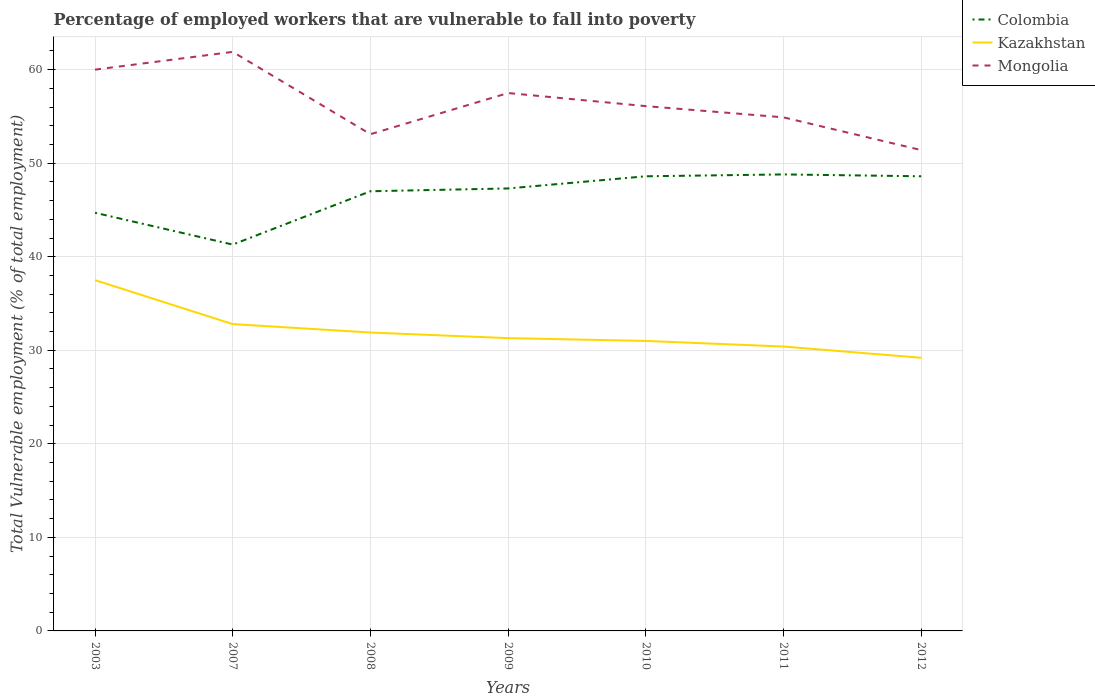How many different coloured lines are there?
Your response must be concise. 3. Does the line corresponding to Mongolia intersect with the line corresponding to Colombia?
Your answer should be very brief. No. Is the number of lines equal to the number of legend labels?
Offer a terse response. Yes. Across all years, what is the maximum percentage of employed workers who are vulnerable to fall into poverty in Colombia?
Keep it short and to the point. 41.3. What is the total percentage of employed workers who are vulnerable to fall into poverty in Colombia in the graph?
Your answer should be very brief. -5.7. What is the difference between the highest and the second highest percentage of employed workers who are vulnerable to fall into poverty in Kazakhstan?
Give a very brief answer. 8.3. What is the difference between the highest and the lowest percentage of employed workers who are vulnerable to fall into poverty in Colombia?
Offer a terse response. 5. Is the percentage of employed workers who are vulnerable to fall into poverty in Colombia strictly greater than the percentage of employed workers who are vulnerable to fall into poverty in Mongolia over the years?
Offer a terse response. Yes. How many years are there in the graph?
Your response must be concise. 7. What is the difference between two consecutive major ticks on the Y-axis?
Offer a terse response. 10. Are the values on the major ticks of Y-axis written in scientific E-notation?
Ensure brevity in your answer.  No. Does the graph contain grids?
Offer a terse response. Yes. Where does the legend appear in the graph?
Your answer should be very brief. Top right. How are the legend labels stacked?
Give a very brief answer. Vertical. What is the title of the graph?
Your answer should be compact. Percentage of employed workers that are vulnerable to fall into poverty. Does "United Kingdom" appear as one of the legend labels in the graph?
Your answer should be very brief. No. What is the label or title of the Y-axis?
Provide a succinct answer. Total Vulnerable employment (% of total employment). What is the Total Vulnerable employment (% of total employment) of Colombia in 2003?
Provide a succinct answer. 44.7. What is the Total Vulnerable employment (% of total employment) of Kazakhstan in 2003?
Your response must be concise. 37.5. What is the Total Vulnerable employment (% of total employment) in Mongolia in 2003?
Offer a very short reply. 60. What is the Total Vulnerable employment (% of total employment) of Colombia in 2007?
Give a very brief answer. 41.3. What is the Total Vulnerable employment (% of total employment) in Kazakhstan in 2007?
Give a very brief answer. 32.8. What is the Total Vulnerable employment (% of total employment) in Mongolia in 2007?
Provide a succinct answer. 61.9. What is the Total Vulnerable employment (% of total employment) of Kazakhstan in 2008?
Make the answer very short. 31.9. What is the Total Vulnerable employment (% of total employment) of Mongolia in 2008?
Offer a very short reply. 53.1. What is the Total Vulnerable employment (% of total employment) in Colombia in 2009?
Offer a terse response. 47.3. What is the Total Vulnerable employment (% of total employment) in Kazakhstan in 2009?
Make the answer very short. 31.3. What is the Total Vulnerable employment (% of total employment) in Mongolia in 2009?
Keep it short and to the point. 57.5. What is the Total Vulnerable employment (% of total employment) in Colombia in 2010?
Your answer should be compact. 48.6. What is the Total Vulnerable employment (% of total employment) of Kazakhstan in 2010?
Your response must be concise. 31. What is the Total Vulnerable employment (% of total employment) of Mongolia in 2010?
Your response must be concise. 56.1. What is the Total Vulnerable employment (% of total employment) of Colombia in 2011?
Your answer should be compact. 48.8. What is the Total Vulnerable employment (% of total employment) in Kazakhstan in 2011?
Offer a terse response. 30.4. What is the Total Vulnerable employment (% of total employment) in Mongolia in 2011?
Keep it short and to the point. 54.9. What is the Total Vulnerable employment (% of total employment) in Colombia in 2012?
Provide a succinct answer. 48.6. What is the Total Vulnerable employment (% of total employment) of Kazakhstan in 2012?
Offer a very short reply. 29.2. What is the Total Vulnerable employment (% of total employment) of Mongolia in 2012?
Give a very brief answer. 51.4. Across all years, what is the maximum Total Vulnerable employment (% of total employment) of Colombia?
Offer a terse response. 48.8. Across all years, what is the maximum Total Vulnerable employment (% of total employment) in Kazakhstan?
Offer a terse response. 37.5. Across all years, what is the maximum Total Vulnerable employment (% of total employment) in Mongolia?
Make the answer very short. 61.9. Across all years, what is the minimum Total Vulnerable employment (% of total employment) in Colombia?
Offer a very short reply. 41.3. Across all years, what is the minimum Total Vulnerable employment (% of total employment) in Kazakhstan?
Your answer should be very brief. 29.2. Across all years, what is the minimum Total Vulnerable employment (% of total employment) of Mongolia?
Your answer should be very brief. 51.4. What is the total Total Vulnerable employment (% of total employment) in Colombia in the graph?
Your answer should be very brief. 326.3. What is the total Total Vulnerable employment (% of total employment) in Kazakhstan in the graph?
Make the answer very short. 224.1. What is the total Total Vulnerable employment (% of total employment) in Mongolia in the graph?
Ensure brevity in your answer.  394.9. What is the difference between the Total Vulnerable employment (% of total employment) in Kazakhstan in 2003 and that in 2007?
Provide a succinct answer. 4.7. What is the difference between the Total Vulnerable employment (% of total employment) of Colombia in 2003 and that in 2008?
Ensure brevity in your answer.  -2.3. What is the difference between the Total Vulnerable employment (% of total employment) of Kazakhstan in 2003 and that in 2008?
Provide a short and direct response. 5.6. What is the difference between the Total Vulnerable employment (% of total employment) of Mongolia in 2003 and that in 2008?
Provide a succinct answer. 6.9. What is the difference between the Total Vulnerable employment (% of total employment) in Colombia in 2003 and that in 2009?
Offer a terse response. -2.6. What is the difference between the Total Vulnerable employment (% of total employment) in Mongolia in 2003 and that in 2009?
Offer a very short reply. 2.5. What is the difference between the Total Vulnerable employment (% of total employment) in Colombia in 2003 and that in 2010?
Your answer should be very brief. -3.9. What is the difference between the Total Vulnerable employment (% of total employment) in Mongolia in 2003 and that in 2010?
Your answer should be very brief. 3.9. What is the difference between the Total Vulnerable employment (% of total employment) of Kazakhstan in 2003 and that in 2011?
Your response must be concise. 7.1. What is the difference between the Total Vulnerable employment (% of total employment) of Mongolia in 2003 and that in 2011?
Offer a terse response. 5.1. What is the difference between the Total Vulnerable employment (% of total employment) in Colombia in 2003 and that in 2012?
Give a very brief answer. -3.9. What is the difference between the Total Vulnerable employment (% of total employment) of Mongolia in 2003 and that in 2012?
Offer a terse response. 8.6. What is the difference between the Total Vulnerable employment (% of total employment) in Colombia in 2007 and that in 2008?
Provide a succinct answer. -5.7. What is the difference between the Total Vulnerable employment (% of total employment) in Kazakhstan in 2007 and that in 2008?
Your response must be concise. 0.9. What is the difference between the Total Vulnerable employment (% of total employment) in Mongolia in 2007 and that in 2008?
Your answer should be compact. 8.8. What is the difference between the Total Vulnerable employment (% of total employment) of Colombia in 2007 and that in 2009?
Keep it short and to the point. -6. What is the difference between the Total Vulnerable employment (% of total employment) of Colombia in 2007 and that in 2010?
Your response must be concise. -7.3. What is the difference between the Total Vulnerable employment (% of total employment) in Mongolia in 2007 and that in 2010?
Provide a short and direct response. 5.8. What is the difference between the Total Vulnerable employment (% of total employment) of Kazakhstan in 2007 and that in 2011?
Make the answer very short. 2.4. What is the difference between the Total Vulnerable employment (% of total employment) of Colombia in 2007 and that in 2012?
Provide a succinct answer. -7.3. What is the difference between the Total Vulnerable employment (% of total employment) of Mongolia in 2008 and that in 2009?
Offer a very short reply. -4.4. What is the difference between the Total Vulnerable employment (% of total employment) of Colombia in 2008 and that in 2010?
Provide a succinct answer. -1.6. What is the difference between the Total Vulnerable employment (% of total employment) in Mongolia in 2008 and that in 2010?
Your response must be concise. -3. What is the difference between the Total Vulnerable employment (% of total employment) in Colombia in 2008 and that in 2011?
Your response must be concise. -1.8. What is the difference between the Total Vulnerable employment (% of total employment) of Kazakhstan in 2009 and that in 2010?
Your response must be concise. 0.3. What is the difference between the Total Vulnerable employment (% of total employment) in Kazakhstan in 2009 and that in 2011?
Your answer should be compact. 0.9. What is the difference between the Total Vulnerable employment (% of total employment) in Colombia in 2009 and that in 2012?
Give a very brief answer. -1.3. What is the difference between the Total Vulnerable employment (% of total employment) of Colombia in 2010 and that in 2011?
Your answer should be very brief. -0.2. What is the difference between the Total Vulnerable employment (% of total employment) of Kazakhstan in 2010 and that in 2011?
Your response must be concise. 0.6. What is the difference between the Total Vulnerable employment (% of total employment) in Mongolia in 2011 and that in 2012?
Your response must be concise. 3.5. What is the difference between the Total Vulnerable employment (% of total employment) in Colombia in 2003 and the Total Vulnerable employment (% of total employment) in Mongolia in 2007?
Give a very brief answer. -17.2. What is the difference between the Total Vulnerable employment (% of total employment) of Kazakhstan in 2003 and the Total Vulnerable employment (% of total employment) of Mongolia in 2007?
Keep it short and to the point. -24.4. What is the difference between the Total Vulnerable employment (% of total employment) in Colombia in 2003 and the Total Vulnerable employment (% of total employment) in Mongolia in 2008?
Your answer should be very brief. -8.4. What is the difference between the Total Vulnerable employment (% of total employment) of Kazakhstan in 2003 and the Total Vulnerable employment (% of total employment) of Mongolia in 2008?
Keep it short and to the point. -15.6. What is the difference between the Total Vulnerable employment (% of total employment) of Colombia in 2003 and the Total Vulnerable employment (% of total employment) of Kazakhstan in 2009?
Offer a very short reply. 13.4. What is the difference between the Total Vulnerable employment (% of total employment) of Colombia in 2003 and the Total Vulnerable employment (% of total employment) of Mongolia in 2009?
Your answer should be very brief. -12.8. What is the difference between the Total Vulnerable employment (% of total employment) in Kazakhstan in 2003 and the Total Vulnerable employment (% of total employment) in Mongolia in 2010?
Your answer should be very brief. -18.6. What is the difference between the Total Vulnerable employment (% of total employment) in Colombia in 2003 and the Total Vulnerable employment (% of total employment) in Kazakhstan in 2011?
Offer a terse response. 14.3. What is the difference between the Total Vulnerable employment (% of total employment) in Colombia in 2003 and the Total Vulnerable employment (% of total employment) in Mongolia in 2011?
Provide a succinct answer. -10.2. What is the difference between the Total Vulnerable employment (% of total employment) in Kazakhstan in 2003 and the Total Vulnerable employment (% of total employment) in Mongolia in 2011?
Your answer should be compact. -17.4. What is the difference between the Total Vulnerable employment (% of total employment) of Colombia in 2003 and the Total Vulnerable employment (% of total employment) of Kazakhstan in 2012?
Your answer should be compact. 15.5. What is the difference between the Total Vulnerable employment (% of total employment) in Colombia in 2003 and the Total Vulnerable employment (% of total employment) in Mongolia in 2012?
Offer a terse response. -6.7. What is the difference between the Total Vulnerable employment (% of total employment) of Kazakhstan in 2003 and the Total Vulnerable employment (% of total employment) of Mongolia in 2012?
Provide a succinct answer. -13.9. What is the difference between the Total Vulnerable employment (% of total employment) in Kazakhstan in 2007 and the Total Vulnerable employment (% of total employment) in Mongolia in 2008?
Ensure brevity in your answer.  -20.3. What is the difference between the Total Vulnerable employment (% of total employment) of Colombia in 2007 and the Total Vulnerable employment (% of total employment) of Kazakhstan in 2009?
Provide a short and direct response. 10. What is the difference between the Total Vulnerable employment (% of total employment) of Colombia in 2007 and the Total Vulnerable employment (% of total employment) of Mongolia in 2009?
Provide a short and direct response. -16.2. What is the difference between the Total Vulnerable employment (% of total employment) of Kazakhstan in 2007 and the Total Vulnerable employment (% of total employment) of Mongolia in 2009?
Offer a terse response. -24.7. What is the difference between the Total Vulnerable employment (% of total employment) in Colombia in 2007 and the Total Vulnerable employment (% of total employment) in Mongolia in 2010?
Make the answer very short. -14.8. What is the difference between the Total Vulnerable employment (% of total employment) of Kazakhstan in 2007 and the Total Vulnerable employment (% of total employment) of Mongolia in 2010?
Give a very brief answer. -23.3. What is the difference between the Total Vulnerable employment (% of total employment) in Kazakhstan in 2007 and the Total Vulnerable employment (% of total employment) in Mongolia in 2011?
Ensure brevity in your answer.  -22.1. What is the difference between the Total Vulnerable employment (% of total employment) in Kazakhstan in 2007 and the Total Vulnerable employment (% of total employment) in Mongolia in 2012?
Keep it short and to the point. -18.6. What is the difference between the Total Vulnerable employment (% of total employment) in Kazakhstan in 2008 and the Total Vulnerable employment (% of total employment) in Mongolia in 2009?
Your response must be concise. -25.6. What is the difference between the Total Vulnerable employment (% of total employment) in Kazakhstan in 2008 and the Total Vulnerable employment (% of total employment) in Mongolia in 2010?
Ensure brevity in your answer.  -24.2. What is the difference between the Total Vulnerable employment (% of total employment) of Colombia in 2008 and the Total Vulnerable employment (% of total employment) of Mongolia in 2011?
Your answer should be compact. -7.9. What is the difference between the Total Vulnerable employment (% of total employment) of Colombia in 2008 and the Total Vulnerable employment (% of total employment) of Kazakhstan in 2012?
Keep it short and to the point. 17.8. What is the difference between the Total Vulnerable employment (% of total employment) in Kazakhstan in 2008 and the Total Vulnerable employment (% of total employment) in Mongolia in 2012?
Give a very brief answer. -19.5. What is the difference between the Total Vulnerable employment (% of total employment) of Colombia in 2009 and the Total Vulnerable employment (% of total employment) of Mongolia in 2010?
Keep it short and to the point. -8.8. What is the difference between the Total Vulnerable employment (% of total employment) in Kazakhstan in 2009 and the Total Vulnerable employment (% of total employment) in Mongolia in 2010?
Offer a terse response. -24.8. What is the difference between the Total Vulnerable employment (% of total employment) of Colombia in 2009 and the Total Vulnerable employment (% of total employment) of Mongolia in 2011?
Offer a terse response. -7.6. What is the difference between the Total Vulnerable employment (% of total employment) of Kazakhstan in 2009 and the Total Vulnerable employment (% of total employment) of Mongolia in 2011?
Offer a very short reply. -23.6. What is the difference between the Total Vulnerable employment (% of total employment) of Colombia in 2009 and the Total Vulnerable employment (% of total employment) of Kazakhstan in 2012?
Offer a very short reply. 18.1. What is the difference between the Total Vulnerable employment (% of total employment) of Colombia in 2009 and the Total Vulnerable employment (% of total employment) of Mongolia in 2012?
Give a very brief answer. -4.1. What is the difference between the Total Vulnerable employment (% of total employment) of Kazakhstan in 2009 and the Total Vulnerable employment (% of total employment) of Mongolia in 2012?
Provide a short and direct response. -20.1. What is the difference between the Total Vulnerable employment (% of total employment) in Colombia in 2010 and the Total Vulnerable employment (% of total employment) in Kazakhstan in 2011?
Ensure brevity in your answer.  18.2. What is the difference between the Total Vulnerable employment (% of total employment) of Colombia in 2010 and the Total Vulnerable employment (% of total employment) of Mongolia in 2011?
Provide a succinct answer. -6.3. What is the difference between the Total Vulnerable employment (% of total employment) in Kazakhstan in 2010 and the Total Vulnerable employment (% of total employment) in Mongolia in 2011?
Give a very brief answer. -23.9. What is the difference between the Total Vulnerable employment (% of total employment) in Colombia in 2010 and the Total Vulnerable employment (% of total employment) in Kazakhstan in 2012?
Offer a terse response. 19.4. What is the difference between the Total Vulnerable employment (% of total employment) of Colombia in 2010 and the Total Vulnerable employment (% of total employment) of Mongolia in 2012?
Offer a very short reply. -2.8. What is the difference between the Total Vulnerable employment (% of total employment) in Kazakhstan in 2010 and the Total Vulnerable employment (% of total employment) in Mongolia in 2012?
Your answer should be compact. -20.4. What is the difference between the Total Vulnerable employment (% of total employment) in Colombia in 2011 and the Total Vulnerable employment (% of total employment) in Kazakhstan in 2012?
Provide a short and direct response. 19.6. What is the difference between the Total Vulnerable employment (% of total employment) in Colombia in 2011 and the Total Vulnerable employment (% of total employment) in Mongolia in 2012?
Provide a succinct answer. -2.6. What is the difference between the Total Vulnerable employment (% of total employment) of Kazakhstan in 2011 and the Total Vulnerable employment (% of total employment) of Mongolia in 2012?
Provide a succinct answer. -21. What is the average Total Vulnerable employment (% of total employment) of Colombia per year?
Your response must be concise. 46.61. What is the average Total Vulnerable employment (% of total employment) of Kazakhstan per year?
Your response must be concise. 32.01. What is the average Total Vulnerable employment (% of total employment) of Mongolia per year?
Your response must be concise. 56.41. In the year 2003, what is the difference between the Total Vulnerable employment (% of total employment) of Colombia and Total Vulnerable employment (% of total employment) of Kazakhstan?
Your answer should be very brief. 7.2. In the year 2003, what is the difference between the Total Vulnerable employment (% of total employment) of Colombia and Total Vulnerable employment (% of total employment) of Mongolia?
Ensure brevity in your answer.  -15.3. In the year 2003, what is the difference between the Total Vulnerable employment (% of total employment) in Kazakhstan and Total Vulnerable employment (% of total employment) in Mongolia?
Keep it short and to the point. -22.5. In the year 2007, what is the difference between the Total Vulnerable employment (% of total employment) of Colombia and Total Vulnerable employment (% of total employment) of Kazakhstan?
Your answer should be compact. 8.5. In the year 2007, what is the difference between the Total Vulnerable employment (% of total employment) in Colombia and Total Vulnerable employment (% of total employment) in Mongolia?
Offer a terse response. -20.6. In the year 2007, what is the difference between the Total Vulnerable employment (% of total employment) of Kazakhstan and Total Vulnerable employment (% of total employment) of Mongolia?
Provide a short and direct response. -29.1. In the year 2008, what is the difference between the Total Vulnerable employment (% of total employment) of Colombia and Total Vulnerable employment (% of total employment) of Mongolia?
Offer a terse response. -6.1. In the year 2008, what is the difference between the Total Vulnerable employment (% of total employment) in Kazakhstan and Total Vulnerable employment (% of total employment) in Mongolia?
Give a very brief answer. -21.2. In the year 2009, what is the difference between the Total Vulnerable employment (% of total employment) in Colombia and Total Vulnerable employment (% of total employment) in Mongolia?
Provide a short and direct response. -10.2. In the year 2009, what is the difference between the Total Vulnerable employment (% of total employment) of Kazakhstan and Total Vulnerable employment (% of total employment) of Mongolia?
Give a very brief answer. -26.2. In the year 2010, what is the difference between the Total Vulnerable employment (% of total employment) in Colombia and Total Vulnerable employment (% of total employment) in Kazakhstan?
Provide a succinct answer. 17.6. In the year 2010, what is the difference between the Total Vulnerable employment (% of total employment) of Kazakhstan and Total Vulnerable employment (% of total employment) of Mongolia?
Provide a short and direct response. -25.1. In the year 2011, what is the difference between the Total Vulnerable employment (% of total employment) in Colombia and Total Vulnerable employment (% of total employment) in Mongolia?
Offer a terse response. -6.1. In the year 2011, what is the difference between the Total Vulnerable employment (% of total employment) of Kazakhstan and Total Vulnerable employment (% of total employment) of Mongolia?
Ensure brevity in your answer.  -24.5. In the year 2012, what is the difference between the Total Vulnerable employment (% of total employment) of Colombia and Total Vulnerable employment (% of total employment) of Kazakhstan?
Provide a short and direct response. 19.4. In the year 2012, what is the difference between the Total Vulnerable employment (% of total employment) of Kazakhstan and Total Vulnerable employment (% of total employment) of Mongolia?
Your answer should be very brief. -22.2. What is the ratio of the Total Vulnerable employment (% of total employment) of Colombia in 2003 to that in 2007?
Give a very brief answer. 1.08. What is the ratio of the Total Vulnerable employment (% of total employment) in Kazakhstan in 2003 to that in 2007?
Your response must be concise. 1.14. What is the ratio of the Total Vulnerable employment (% of total employment) in Mongolia in 2003 to that in 2007?
Make the answer very short. 0.97. What is the ratio of the Total Vulnerable employment (% of total employment) in Colombia in 2003 to that in 2008?
Offer a terse response. 0.95. What is the ratio of the Total Vulnerable employment (% of total employment) in Kazakhstan in 2003 to that in 2008?
Provide a succinct answer. 1.18. What is the ratio of the Total Vulnerable employment (% of total employment) of Mongolia in 2003 to that in 2008?
Ensure brevity in your answer.  1.13. What is the ratio of the Total Vulnerable employment (% of total employment) of Colombia in 2003 to that in 2009?
Offer a very short reply. 0.94. What is the ratio of the Total Vulnerable employment (% of total employment) in Kazakhstan in 2003 to that in 2009?
Offer a terse response. 1.2. What is the ratio of the Total Vulnerable employment (% of total employment) of Mongolia in 2003 to that in 2009?
Provide a succinct answer. 1.04. What is the ratio of the Total Vulnerable employment (% of total employment) in Colombia in 2003 to that in 2010?
Your response must be concise. 0.92. What is the ratio of the Total Vulnerable employment (% of total employment) in Kazakhstan in 2003 to that in 2010?
Your response must be concise. 1.21. What is the ratio of the Total Vulnerable employment (% of total employment) in Mongolia in 2003 to that in 2010?
Your response must be concise. 1.07. What is the ratio of the Total Vulnerable employment (% of total employment) of Colombia in 2003 to that in 2011?
Provide a short and direct response. 0.92. What is the ratio of the Total Vulnerable employment (% of total employment) of Kazakhstan in 2003 to that in 2011?
Provide a short and direct response. 1.23. What is the ratio of the Total Vulnerable employment (% of total employment) in Mongolia in 2003 to that in 2011?
Offer a terse response. 1.09. What is the ratio of the Total Vulnerable employment (% of total employment) of Colombia in 2003 to that in 2012?
Offer a very short reply. 0.92. What is the ratio of the Total Vulnerable employment (% of total employment) of Kazakhstan in 2003 to that in 2012?
Your answer should be compact. 1.28. What is the ratio of the Total Vulnerable employment (% of total employment) in Mongolia in 2003 to that in 2012?
Make the answer very short. 1.17. What is the ratio of the Total Vulnerable employment (% of total employment) of Colombia in 2007 to that in 2008?
Make the answer very short. 0.88. What is the ratio of the Total Vulnerable employment (% of total employment) of Kazakhstan in 2007 to that in 2008?
Offer a very short reply. 1.03. What is the ratio of the Total Vulnerable employment (% of total employment) of Mongolia in 2007 to that in 2008?
Provide a succinct answer. 1.17. What is the ratio of the Total Vulnerable employment (% of total employment) in Colombia in 2007 to that in 2009?
Your response must be concise. 0.87. What is the ratio of the Total Vulnerable employment (% of total employment) of Kazakhstan in 2007 to that in 2009?
Provide a succinct answer. 1.05. What is the ratio of the Total Vulnerable employment (% of total employment) in Mongolia in 2007 to that in 2009?
Make the answer very short. 1.08. What is the ratio of the Total Vulnerable employment (% of total employment) of Colombia in 2007 to that in 2010?
Offer a very short reply. 0.85. What is the ratio of the Total Vulnerable employment (% of total employment) in Kazakhstan in 2007 to that in 2010?
Provide a succinct answer. 1.06. What is the ratio of the Total Vulnerable employment (% of total employment) in Mongolia in 2007 to that in 2010?
Provide a short and direct response. 1.1. What is the ratio of the Total Vulnerable employment (% of total employment) of Colombia in 2007 to that in 2011?
Offer a very short reply. 0.85. What is the ratio of the Total Vulnerable employment (% of total employment) in Kazakhstan in 2007 to that in 2011?
Your response must be concise. 1.08. What is the ratio of the Total Vulnerable employment (% of total employment) of Mongolia in 2007 to that in 2011?
Make the answer very short. 1.13. What is the ratio of the Total Vulnerable employment (% of total employment) in Colombia in 2007 to that in 2012?
Your answer should be very brief. 0.85. What is the ratio of the Total Vulnerable employment (% of total employment) of Kazakhstan in 2007 to that in 2012?
Your answer should be very brief. 1.12. What is the ratio of the Total Vulnerable employment (% of total employment) of Mongolia in 2007 to that in 2012?
Offer a terse response. 1.2. What is the ratio of the Total Vulnerable employment (% of total employment) in Colombia in 2008 to that in 2009?
Provide a short and direct response. 0.99. What is the ratio of the Total Vulnerable employment (% of total employment) of Kazakhstan in 2008 to that in 2009?
Offer a very short reply. 1.02. What is the ratio of the Total Vulnerable employment (% of total employment) in Mongolia in 2008 to that in 2009?
Make the answer very short. 0.92. What is the ratio of the Total Vulnerable employment (% of total employment) of Colombia in 2008 to that in 2010?
Provide a succinct answer. 0.97. What is the ratio of the Total Vulnerable employment (% of total employment) in Mongolia in 2008 to that in 2010?
Offer a terse response. 0.95. What is the ratio of the Total Vulnerable employment (% of total employment) of Colombia in 2008 to that in 2011?
Give a very brief answer. 0.96. What is the ratio of the Total Vulnerable employment (% of total employment) in Kazakhstan in 2008 to that in 2011?
Your answer should be compact. 1.05. What is the ratio of the Total Vulnerable employment (% of total employment) in Mongolia in 2008 to that in 2011?
Provide a short and direct response. 0.97. What is the ratio of the Total Vulnerable employment (% of total employment) of Colombia in 2008 to that in 2012?
Ensure brevity in your answer.  0.97. What is the ratio of the Total Vulnerable employment (% of total employment) in Kazakhstan in 2008 to that in 2012?
Make the answer very short. 1.09. What is the ratio of the Total Vulnerable employment (% of total employment) in Mongolia in 2008 to that in 2012?
Your answer should be compact. 1.03. What is the ratio of the Total Vulnerable employment (% of total employment) in Colombia in 2009 to that in 2010?
Offer a terse response. 0.97. What is the ratio of the Total Vulnerable employment (% of total employment) of Kazakhstan in 2009 to that in 2010?
Provide a short and direct response. 1.01. What is the ratio of the Total Vulnerable employment (% of total employment) of Mongolia in 2009 to that in 2010?
Your response must be concise. 1.02. What is the ratio of the Total Vulnerable employment (% of total employment) of Colombia in 2009 to that in 2011?
Your response must be concise. 0.97. What is the ratio of the Total Vulnerable employment (% of total employment) in Kazakhstan in 2009 to that in 2011?
Make the answer very short. 1.03. What is the ratio of the Total Vulnerable employment (% of total employment) in Mongolia in 2009 to that in 2011?
Your response must be concise. 1.05. What is the ratio of the Total Vulnerable employment (% of total employment) in Colombia in 2009 to that in 2012?
Keep it short and to the point. 0.97. What is the ratio of the Total Vulnerable employment (% of total employment) in Kazakhstan in 2009 to that in 2012?
Make the answer very short. 1.07. What is the ratio of the Total Vulnerable employment (% of total employment) of Mongolia in 2009 to that in 2012?
Offer a very short reply. 1.12. What is the ratio of the Total Vulnerable employment (% of total employment) of Colombia in 2010 to that in 2011?
Ensure brevity in your answer.  1. What is the ratio of the Total Vulnerable employment (% of total employment) in Kazakhstan in 2010 to that in 2011?
Offer a terse response. 1.02. What is the ratio of the Total Vulnerable employment (% of total employment) in Mongolia in 2010 to that in 2011?
Your answer should be very brief. 1.02. What is the ratio of the Total Vulnerable employment (% of total employment) of Colombia in 2010 to that in 2012?
Your response must be concise. 1. What is the ratio of the Total Vulnerable employment (% of total employment) in Kazakhstan in 2010 to that in 2012?
Provide a succinct answer. 1.06. What is the ratio of the Total Vulnerable employment (% of total employment) of Mongolia in 2010 to that in 2012?
Your answer should be compact. 1.09. What is the ratio of the Total Vulnerable employment (% of total employment) of Colombia in 2011 to that in 2012?
Your answer should be very brief. 1. What is the ratio of the Total Vulnerable employment (% of total employment) of Kazakhstan in 2011 to that in 2012?
Keep it short and to the point. 1.04. What is the ratio of the Total Vulnerable employment (% of total employment) in Mongolia in 2011 to that in 2012?
Give a very brief answer. 1.07. What is the difference between the highest and the second highest Total Vulnerable employment (% of total employment) in Colombia?
Your answer should be very brief. 0.2. What is the difference between the highest and the lowest Total Vulnerable employment (% of total employment) of Colombia?
Provide a succinct answer. 7.5. 